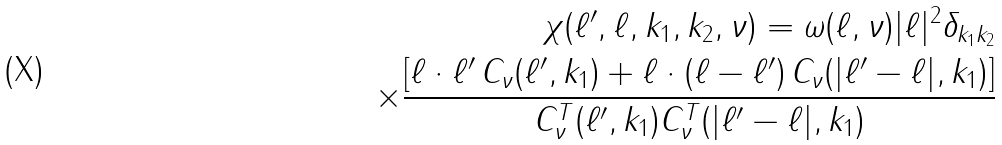<formula> <loc_0><loc_0><loc_500><loc_500>\chi ( \ell ^ { \prime } , \ell , k _ { 1 } , k _ { 2 } , \nu ) = \omega ( \ell , \nu ) | \ell | ^ { 2 } \delta _ { k _ { 1 } k _ { 2 } } \\ \times \frac { \left [ \ell \cdot \ell ^ { \prime } \, C _ { \nu } ( \ell ^ { \prime } , k _ { 1 } ) + \ell \cdot ( \ell - \ell ^ { \prime } ) \, C _ { \nu } ( | \ell ^ { \prime } - \ell | , k _ { 1 } ) \right ] } { C ^ { T } _ { \nu } ( \ell ^ { \prime } , k _ { 1 } ) C ^ { T } _ { \nu } ( | \ell ^ { \prime } - \ell | , k _ { 1 } ) }</formula> 